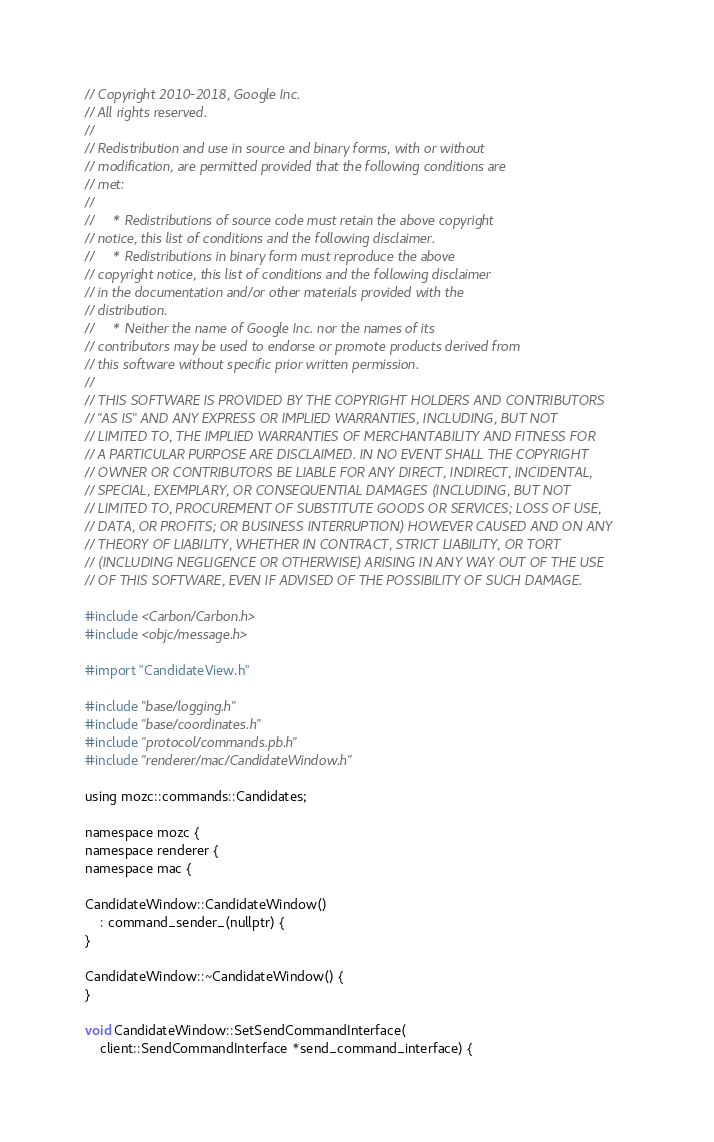<code> <loc_0><loc_0><loc_500><loc_500><_ObjectiveC_>// Copyright 2010-2018, Google Inc.
// All rights reserved.
//
// Redistribution and use in source and binary forms, with or without
// modification, are permitted provided that the following conditions are
// met:
//
//     * Redistributions of source code must retain the above copyright
// notice, this list of conditions and the following disclaimer.
//     * Redistributions in binary form must reproduce the above
// copyright notice, this list of conditions and the following disclaimer
// in the documentation and/or other materials provided with the
// distribution.
//     * Neither the name of Google Inc. nor the names of its
// contributors may be used to endorse or promote products derived from
// this software without specific prior written permission.
//
// THIS SOFTWARE IS PROVIDED BY THE COPYRIGHT HOLDERS AND CONTRIBUTORS
// "AS IS" AND ANY EXPRESS OR IMPLIED WARRANTIES, INCLUDING, BUT NOT
// LIMITED TO, THE IMPLIED WARRANTIES OF MERCHANTABILITY AND FITNESS FOR
// A PARTICULAR PURPOSE ARE DISCLAIMED. IN NO EVENT SHALL THE COPYRIGHT
// OWNER OR CONTRIBUTORS BE LIABLE FOR ANY DIRECT, INDIRECT, INCIDENTAL,
// SPECIAL, EXEMPLARY, OR CONSEQUENTIAL DAMAGES (INCLUDING, BUT NOT
// LIMITED TO, PROCUREMENT OF SUBSTITUTE GOODS OR SERVICES; LOSS OF USE,
// DATA, OR PROFITS; OR BUSINESS INTERRUPTION) HOWEVER CAUSED AND ON ANY
// THEORY OF LIABILITY, WHETHER IN CONTRACT, STRICT LIABILITY, OR TORT
// (INCLUDING NEGLIGENCE OR OTHERWISE) ARISING IN ANY WAY OUT OF THE USE
// OF THIS SOFTWARE, EVEN IF ADVISED OF THE POSSIBILITY OF SUCH DAMAGE.

#include <Carbon/Carbon.h>
#include <objc/message.h>

#import "CandidateView.h"

#include "base/logging.h"
#include "base/coordinates.h"
#include "protocol/commands.pb.h"
#include "renderer/mac/CandidateWindow.h"

using mozc::commands::Candidates;

namespace mozc {
namespace renderer {
namespace mac {

CandidateWindow::CandidateWindow()
    : command_sender_(nullptr) {
}

CandidateWindow::~CandidateWindow() {
}

void CandidateWindow::SetSendCommandInterface(
    client::SendCommandInterface *send_command_interface) {</code> 